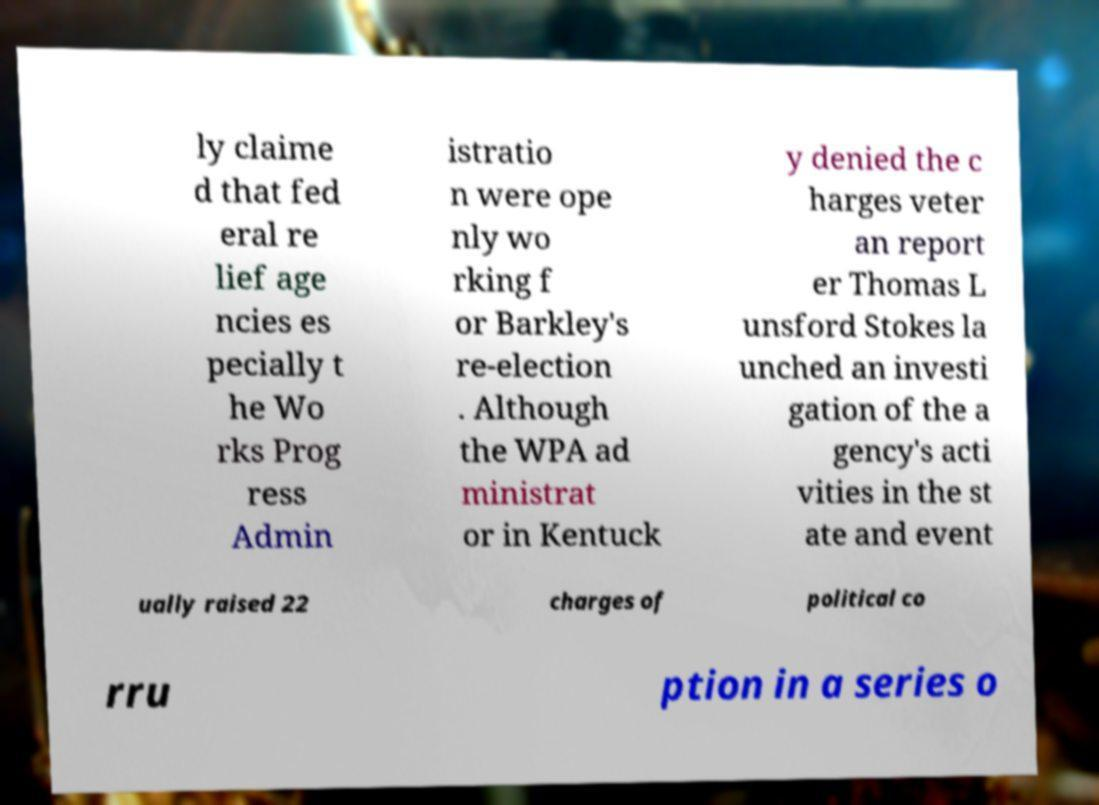Can you accurately transcribe the text from the provided image for me? ly claime d that fed eral re lief age ncies es pecially t he Wo rks Prog ress Admin istratio n were ope nly wo rking f or Barkley's re-election . Although the WPA ad ministrat or in Kentuck y denied the c harges veter an report er Thomas L unsford Stokes la unched an investi gation of the a gency's acti vities in the st ate and event ually raised 22 charges of political co rru ption in a series o 